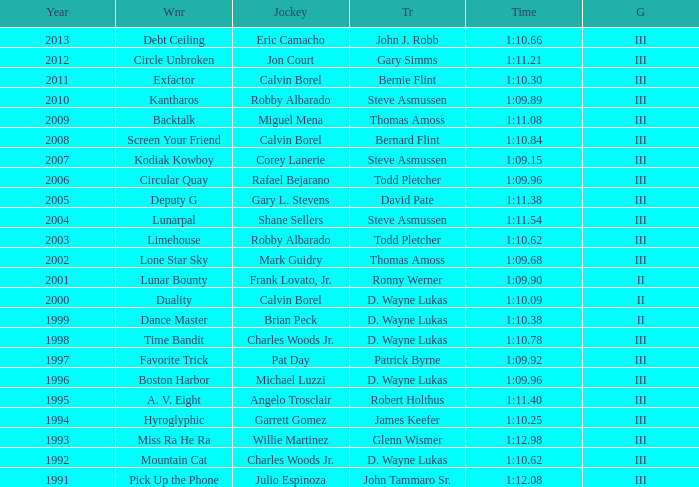Who won under Gary Simms? Circle Unbroken. 